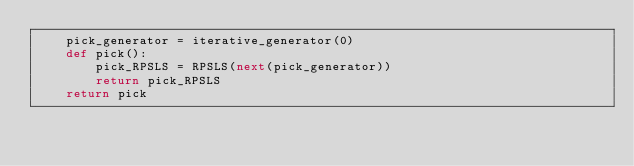<code> <loc_0><loc_0><loc_500><loc_500><_Python_>    pick_generator = iterative_generator(0)
    def pick():
        pick_RPSLS = RPSLS(next(pick_generator))
        return pick_RPSLS
    return pick

    </code> 